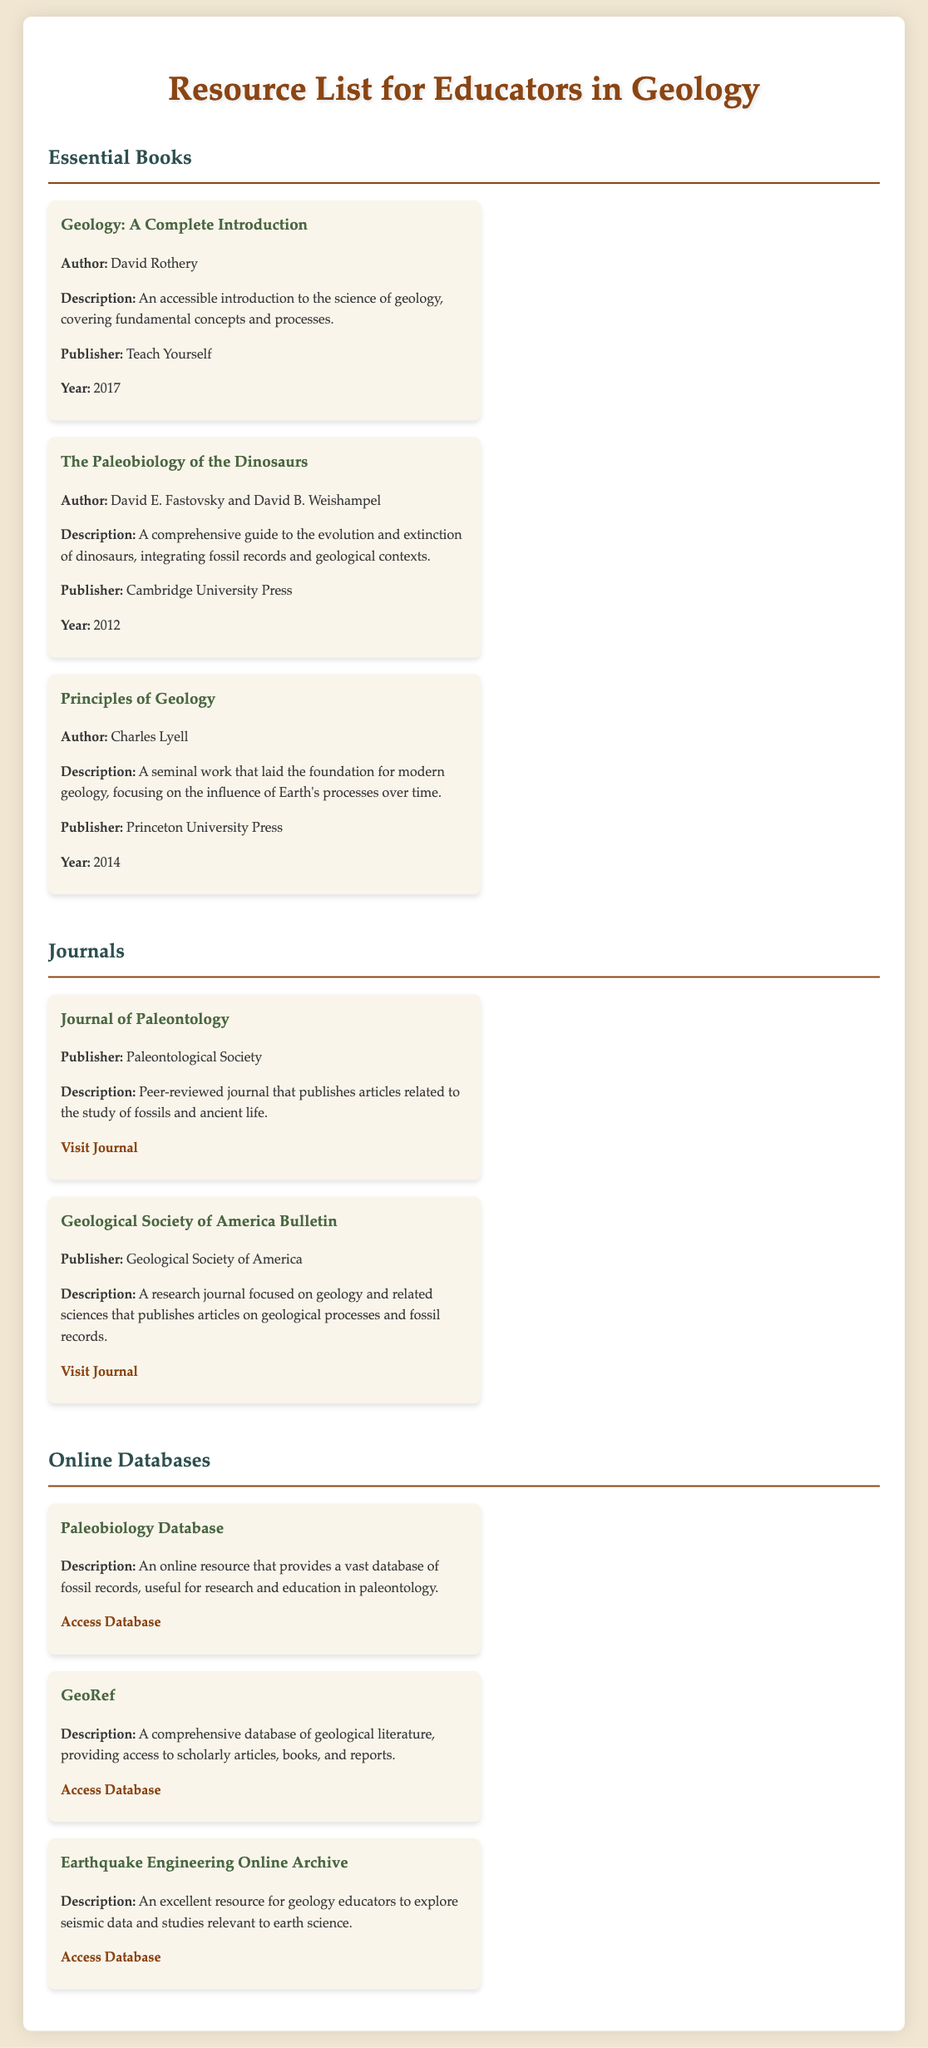what is the title of the first book listed? The title of the first book in the Essential Books section is provided in the document.
Answer: Geology: A Complete Introduction who are the authors of "The Paleobiology of the Dinosaurs"? The authors are mentioned under the book's title in the document.
Answer: David E. Fastovsky and David B. Weishampel what is the publication year of "Principles of Geology"? The published year is listed in the section describing the book.
Answer: 2014 which journal is published by the Paleontological Society? The journal details are provided in the Journals section, which includes the publisher's name.
Answer: Journal of Paleontology how many online databases are listed in the document? The number of online databases is determined by counting the entries in the Online Databases section.
Answer: 3 what is the description focus of the Geological Society of America Bulletin? The description specifies the subjects and content area of the journal.
Answer: Geology and related sciences who is the publisher of "Geology: A Complete Introduction"? The publisher information is included in the book's description.
Answer: Teach Yourself what is the link to access the Paleobiology Database? The link is stated in the description of the database within the document.
Answer: https://paleobiodb.org/ 